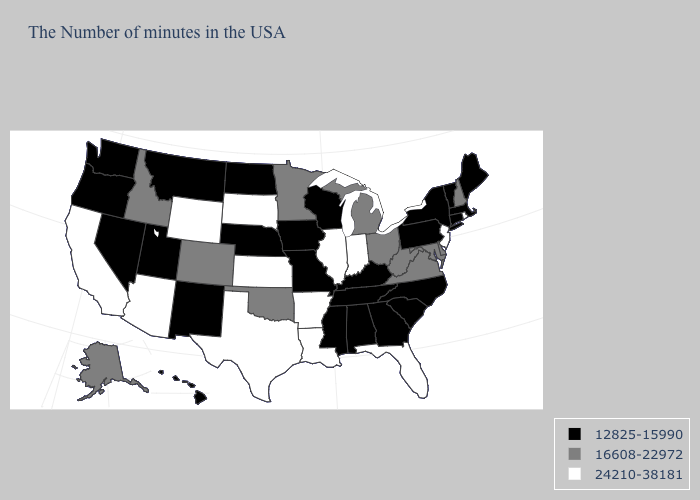Is the legend a continuous bar?
Short answer required. No. Which states have the highest value in the USA?
Answer briefly. Rhode Island, New Jersey, Florida, Indiana, Illinois, Louisiana, Arkansas, Kansas, Texas, South Dakota, Wyoming, Arizona, California. Name the states that have a value in the range 16608-22972?
Be succinct. New Hampshire, Delaware, Maryland, Virginia, West Virginia, Ohio, Michigan, Minnesota, Oklahoma, Colorado, Idaho, Alaska. Is the legend a continuous bar?
Answer briefly. No. What is the highest value in the South ?
Answer briefly. 24210-38181. Name the states that have a value in the range 12825-15990?
Give a very brief answer. Maine, Massachusetts, Vermont, Connecticut, New York, Pennsylvania, North Carolina, South Carolina, Georgia, Kentucky, Alabama, Tennessee, Wisconsin, Mississippi, Missouri, Iowa, Nebraska, North Dakota, New Mexico, Utah, Montana, Nevada, Washington, Oregon, Hawaii. Name the states that have a value in the range 24210-38181?
Short answer required. Rhode Island, New Jersey, Florida, Indiana, Illinois, Louisiana, Arkansas, Kansas, Texas, South Dakota, Wyoming, Arizona, California. Which states have the lowest value in the Northeast?
Answer briefly. Maine, Massachusetts, Vermont, Connecticut, New York, Pennsylvania. What is the highest value in the West ?
Answer briefly. 24210-38181. Name the states that have a value in the range 24210-38181?
Quick response, please. Rhode Island, New Jersey, Florida, Indiana, Illinois, Louisiana, Arkansas, Kansas, Texas, South Dakota, Wyoming, Arizona, California. Does New Jersey have the highest value in the USA?
Quick response, please. Yes. Does the first symbol in the legend represent the smallest category?
Quick response, please. Yes. Does Idaho have the lowest value in the USA?
Be succinct. No. Does the map have missing data?
Give a very brief answer. No. 